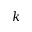<formula> <loc_0><loc_0><loc_500><loc_500>k</formula> 